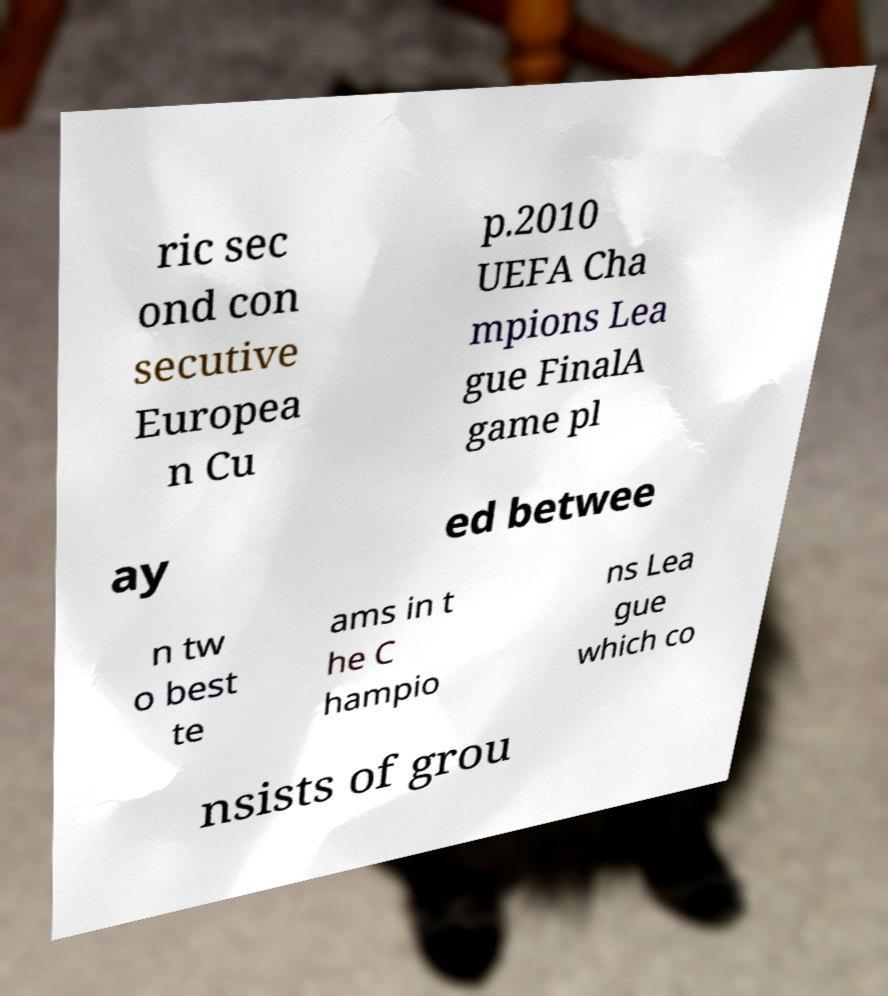I need the written content from this picture converted into text. Can you do that? ric sec ond con secutive Europea n Cu p.2010 UEFA Cha mpions Lea gue FinalA game pl ay ed betwee n tw o best te ams in t he C hampio ns Lea gue which co nsists of grou 